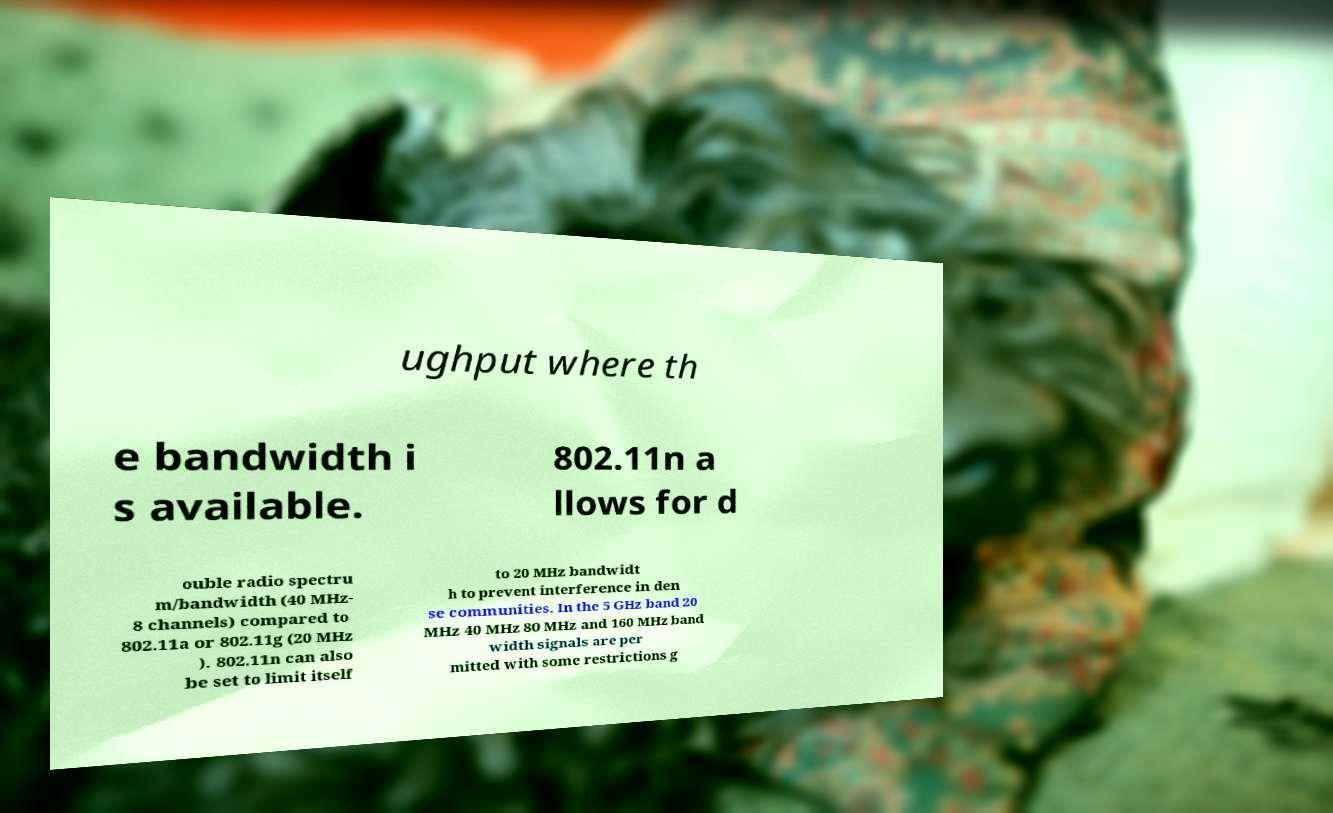Can you read and provide the text displayed in the image?This photo seems to have some interesting text. Can you extract and type it out for me? ughput where th e bandwidth i s available. 802.11n a llows for d ouble radio spectru m/bandwidth (40 MHz- 8 channels) compared to 802.11a or 802.11g (20 MHz ). 802.11n can also be set to limit itself to 20 MHz bandwidt h to prevent interference in den se communities. In the 5 GHz band 20 MHz 40 MHz 80 MHz and 160 MHz band width signals are per mitted with some restrictions g 